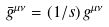Convert formula to latex. <formula><loc_0><loc_0><loc_500><loc_500>\bar { g } ^ { \mu \nu } = ( 1 / s ) \, g ^ { \mu \nu }</formula> 